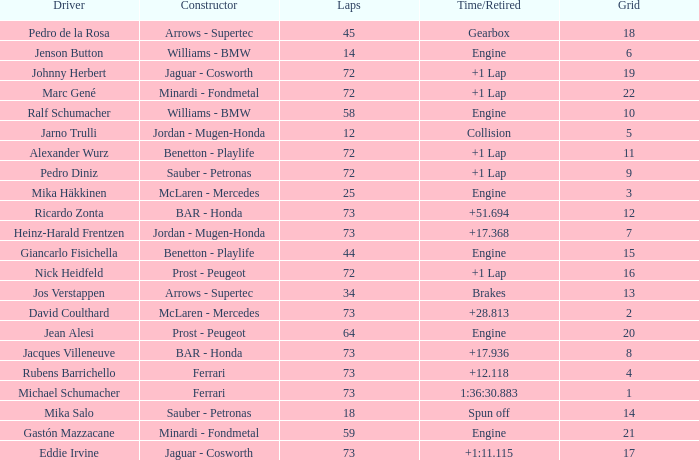How many laps did Giancarlo Fisichella do with a grid larger than 15? 0.0. 